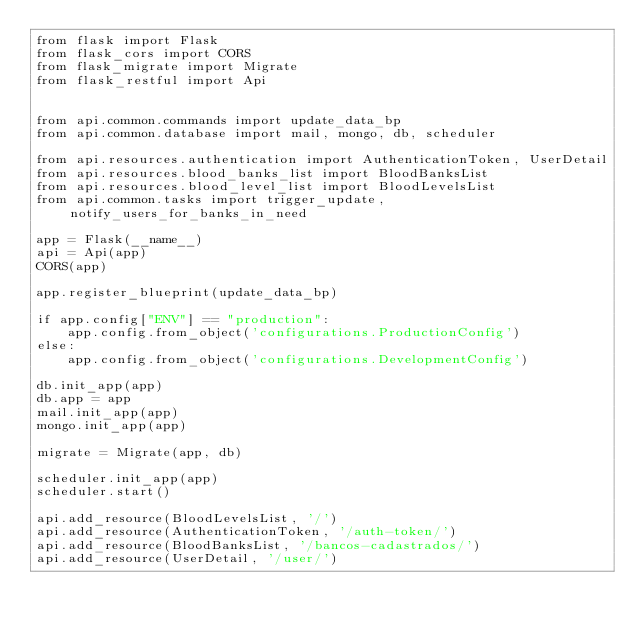Convert code to text. <code><loc_0><loc_0><loc_500><loc_500><_Python_>from flask import Flask
from flask_cors import CORS
from flask_migrate import Migrate
from flask_restful import Api


from api.common.commands import update_data_bp
from api.common.database import mail, mongo, db, scheduler

from api.resources.authentication import AuthenticationToken, UserDetail
from api.resources.blood_banks_list import BloodBanksList
from api.resources.blood_level_list import BloodLevelsList
from api.common.tasks import trigger_update, notify_users_for_banks_in_need

app = Flask(__name__)
api = Api(app)
CORS(app)

app.register_blueprint(update_data_bp)

if app.config["ENV"] == "production":
    app.config.from_object('configurations.ProductionConfig')
else:
    app.config.from_object('configurations.DevelopmentConfig')

db.init_app(app)
db.app = app
mail.init_app(app)
mongo.init_app(app)

migrate = Migrate(app, db)

scheduler.init_app(app)
scheduler.start()

api.add_resource(BloodLevelsList, '/')
api.add_resource(AuthenticationToken, '/auth-token/')
api.add_resource(BloodBanksList, '/bancos-cadastrados/')
api.add_resource(UserDetail, '/user/')</code> 